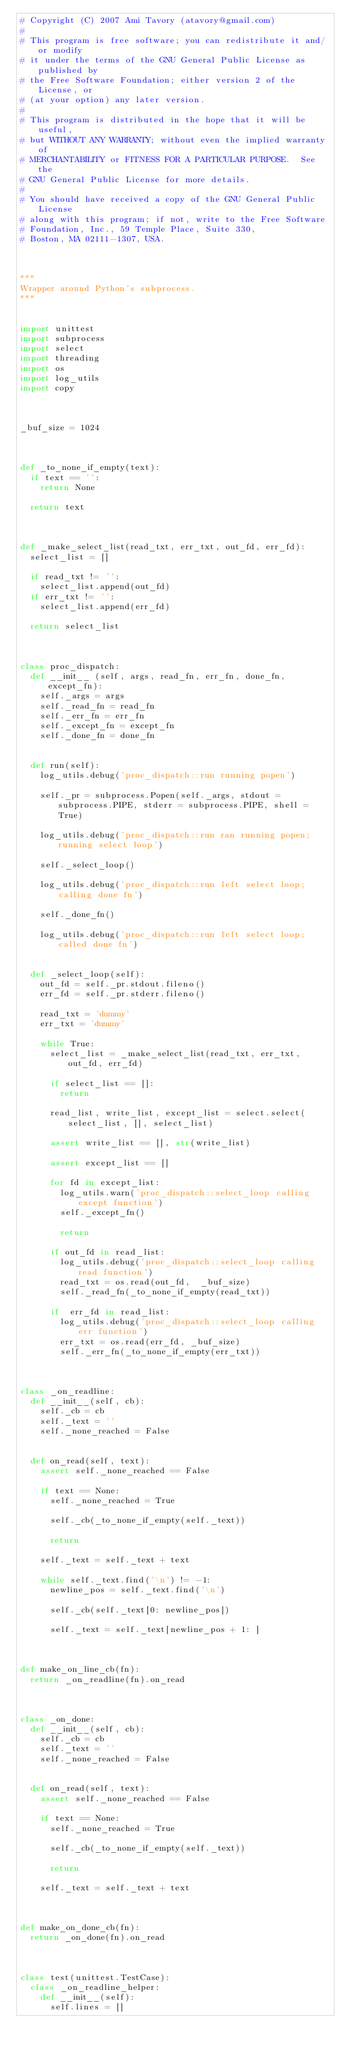<code> <loc_0><loc_0><loc_500><loc_500><_Python_># Copyright (C) 2007 Ami Tavory (atavory@gmail.com)
#
# This program is free software; you can redistribute it and/or modify
# it under the terms of the GNU General Public License as published by
# the Free Software Foundation; either version 2 of the License, or
# (at your option) any later version.
#
# This program is distributed in the hope that it will be useful,
# but WITHOUT ANY WARRANTY; without even the implied warranty of
# MERCHANTABILITY or FITNESS FOR A PARTICULAR PURPOSE.  See the
# GNU General Public License for more details.
#
# You should have received a copy of the GNU General Public License
# along with this program; if not, write to the Free Software
# Foundation, Inc., 59 Temple Place, Suite 330, 
# Boston, MA 02111-1307, USA.



"""
Wrapper around Python's subprocess.
"""


import unittest
import subprocess
import select
import threading
import os
import log_utils
import copy



_buf_size = 1024



def _to_none_if_empty(text):
	if text == '':
		return None
		
	return text



def _make_select_list(read_txt, err_txt, out_fd, err_fd):
	select_list = []
	
	if read_txt != '':
		select_list.append(out_fd)
	if err_txt != '':
		select_list.append(err_fd)

	return select_list



class proc_dispatch:
	def __init__ (self, args, read_fn, err_fn, done_fn, except_fn):
		self._args = args
		self._read_fn = read_fn
		self._err_fn = err_fn
		self._except_fn = except_fn		
		self._done_fn = done_fn
			
		
	def run(self):
		log_utils.debug('proc_dispatch::run running popen')
	
		self._pr = subprocess.Popen(self._args, stdout = subprocess.PIPE, stderr = subprocess.PIPE, shell = True)
		
		log_utils.debug('proc_dispatch::run ran running popen; running select loop')

		self._select_loop()		
		
		log_utils.debug('proc_dispatch::run left select loop; calling done fn')
		
		self._done_fn()
		
		log_utils.debug('proc_dispatch::run left select loop; called done fn')


	def _select_loop(self):
		out_fd = self._pr.stdout.fileno()
		err_fd = self._pr.stderr.fileno()
		
		read_txt = 'dummy'
		err_txt = 'dummy'

		while True:
			select_list = _make_select_list(read_txt, err_txt, out_fd, err_fd)
			
			if select_list == []:
				return

			read_list, write_list, except_list = select.select(select_list, [], select_list)
			
			assert write_list == [], str(write_list)
			
			assert except_list == []
			
			for fd in except_list:
				log_utils.warn('proc_dispatch::select_loop calling except function')
				self._except_fn()
				
				return
	
			if out_fd in read_list:
				log_utils.debug('proc_dispatch::select_loop calling read function')
				read_txt = os.read(out_fd,  _buf_size)
				self._read_fn(_to_none_if_empty(read_txt))
				
			if	err_fd in read_list:
				log_utils.debug('proc_dispatch::select_loop calling err function')
				err_txt = os.read(err_fd, _buf_size)
				self._err_fn(_to_none_if_empty(err_txt))					
				
				
				
class _on_readline:
	def __init__(self, cb):
		self._cb = cb
		self._text = ''
		self._none_reached = False
		
		
	def on_read(self, text):
		assert self._none_reached == False
		
		if text == None:
			self._none_reached = True
		
			self._cb(_to_none_if_empty(self._text))
			
			return
	
		self._text = self._text + text		
		
		while self._text.find('\n') != -1:
			newline_pos = self._text.find('\n')
		
			self._cb(self._text[0: newline_pos])
			
			self._text = self._text[newline_pos + 1: ]
				
				

def make_on_line_cb(fn):
	return _on_readline(fn).on_read



class _on_done:
	def __init__(self, cb):
		self._cb = cb
		self._text = ''
		self._none_reached = False
		
		
	def on_read(self, text):
		assert self._none_reached == False
		
		if text == None:
			self._none_reached = True
		
			self._cb(_to_none_if_empty(self._text))
			
			return
	
		self._text = self._text + text		
		

				
def make_on_done_cb(fn):
	return _on_done(fn).on_read



class test(unittest.TestCase):		
	class _on_readline_helper:
		def __init__(self):
			self.lines = []
			
			</code> 